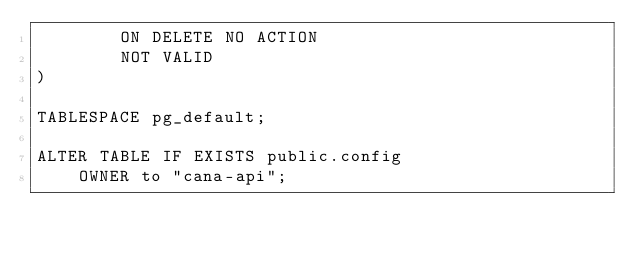Convert code to text. <code><loc_0><loc_0><loc_500><loc_500><_SQL_>        ON DELETE NO ACTION
        NOT VALID
)

TABLESPACE pg_default;

ALTER TABLE IF EXISTS public.config
    OWNER to "cana-api";</code> 